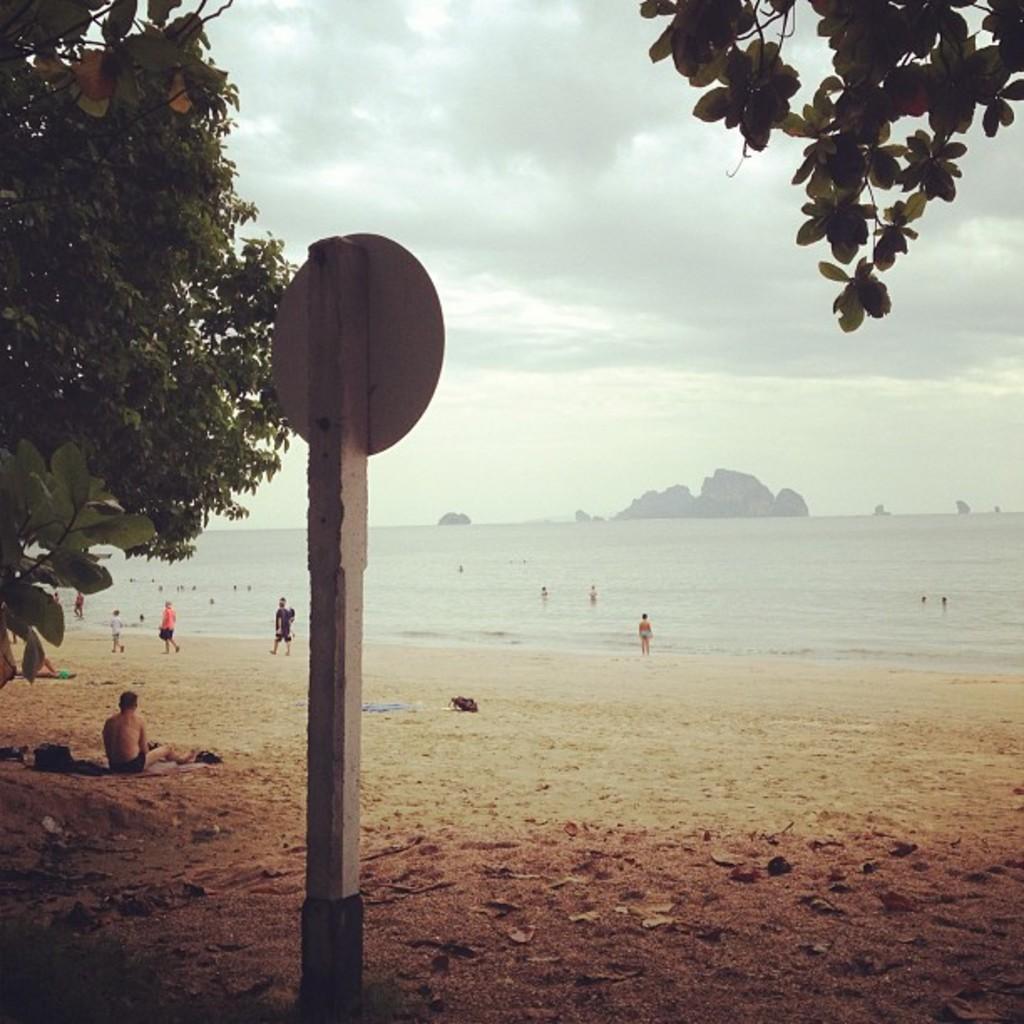Describe this image in one or two sentences. In this image, we can see a pole, board and leaves. Background we can see few people, water and cloudy sky. Here it seems like hills. 